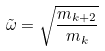Convert formula to latex. <formula><loc_0><loc_0><loc_500><loc_500>\tilde { \omega } = \sqrt { \frac { m _ { k + 2 } } { m _ { k } } }</formula> 